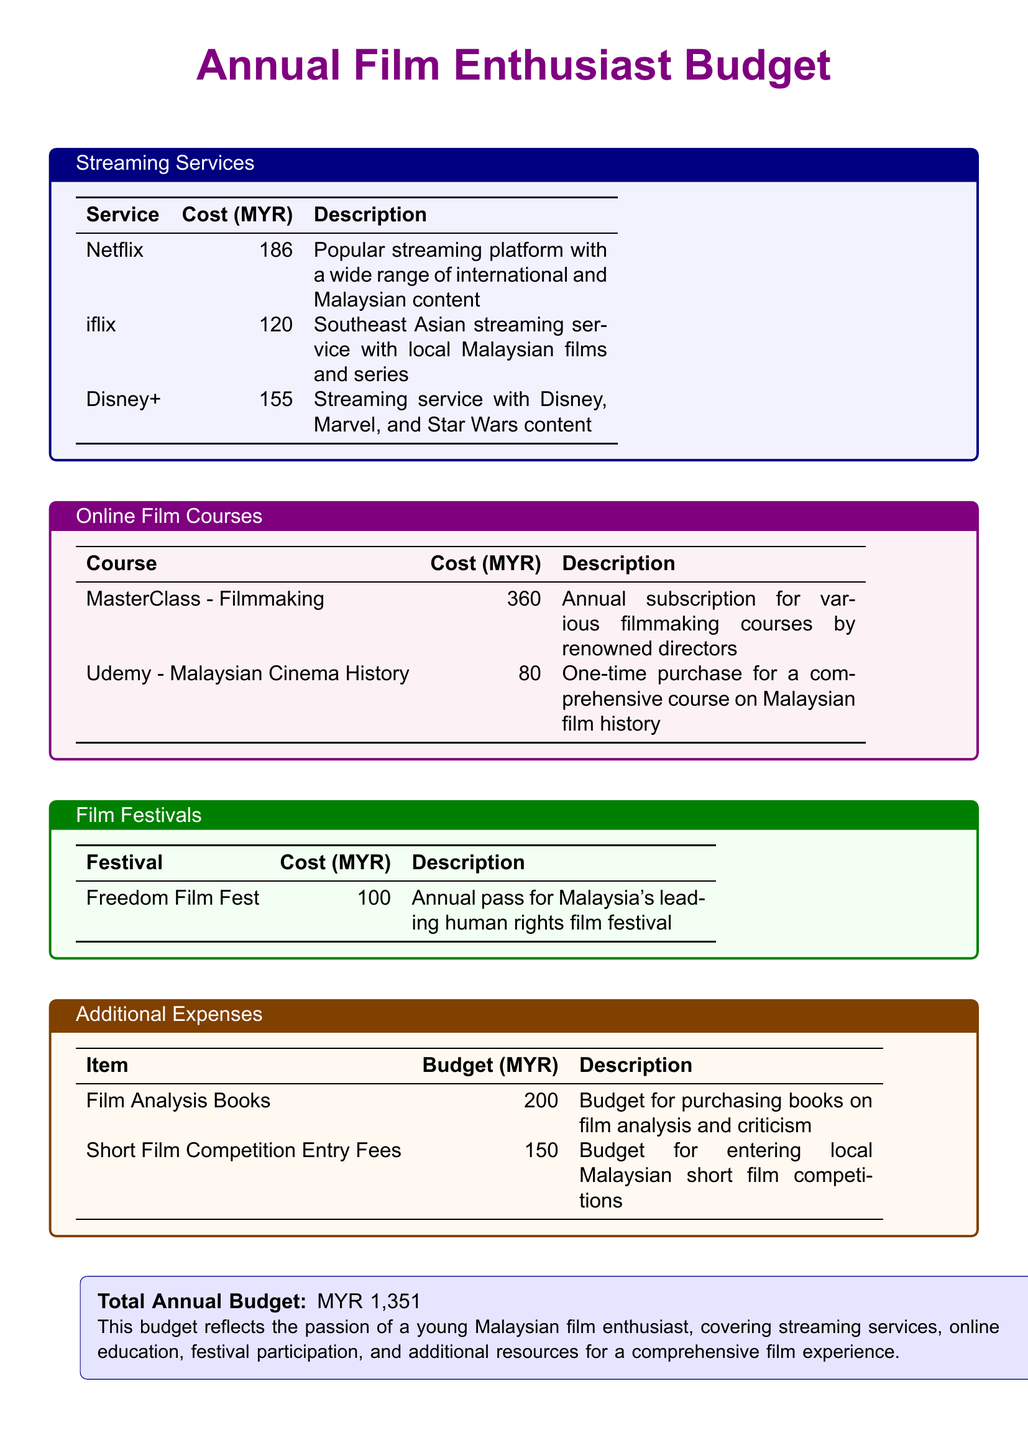What is the total annual budget? The total annual budget is stated in the document, summarizing the costs from all categories.
Answer: MYR 1,351 How much is the subscription for Netflix? The document specifies the cost of the Netflix subscription in the streaming services section.
Answer: 186 What course costs 80 MYR? This question requires identifying the specific course within the online film courses section based on the listed cost.
Answer: Udemy - Malaysian Cinema History Which film festival has a cost of 100 MYR? The cost for attending a specific film festival is mentioned in the film festivals section, indicating the annual pass price.
Answer: Freedom Film Fest What is the budget for film analysis books? This budget item can be found in the additional expenses section, detailing how much is set aside for purchasing books.
Answer: 200 How much does the MasterClass - Filmmaking course cost? The document includes the cost associated with the MasterClass, falling under online film courses.
Answer: 360 What is the cost of entering local Malaysian short film competitions? This expense is discussed in the additional expenses section, indicating specific competitive participation costs.
Answer: 150 Which streaming service features Disney content? This requires combining knowledge of streaming services with specific content offerings mentioned in the document.
Answer: Disney+ How many streaming services are listed in the budget? The document outlines multiple streaming services, which can be counted for a total.
Answer: 3 